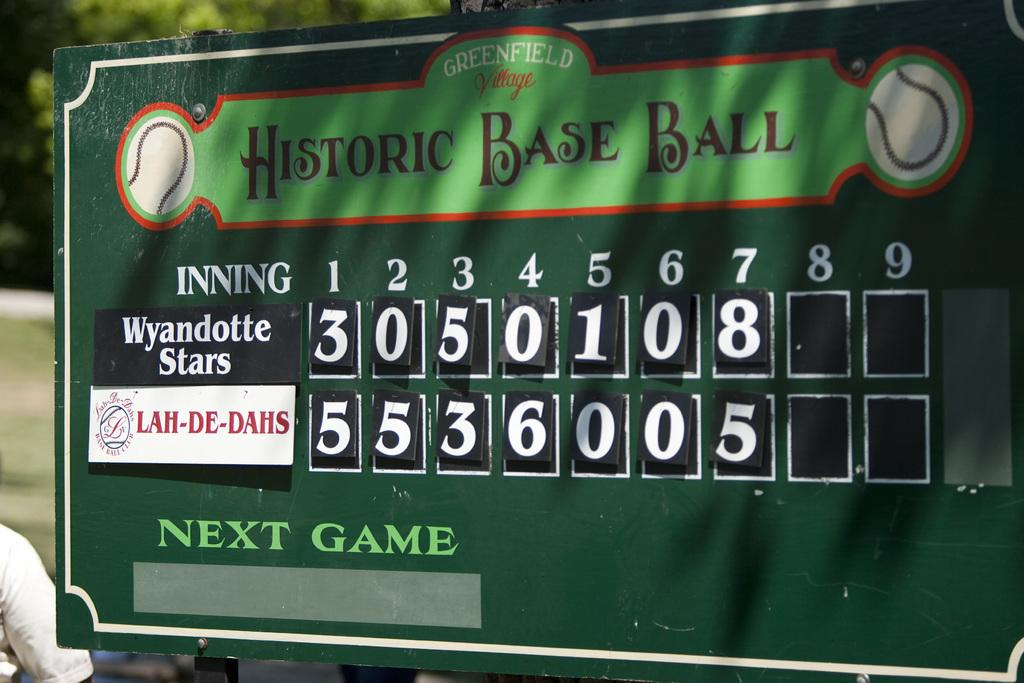<image>
Render a clear and concise summary of the photo. The Greenfield Village historic base ball sign shows a game between the Stars and the Lah-De-Dahs. 